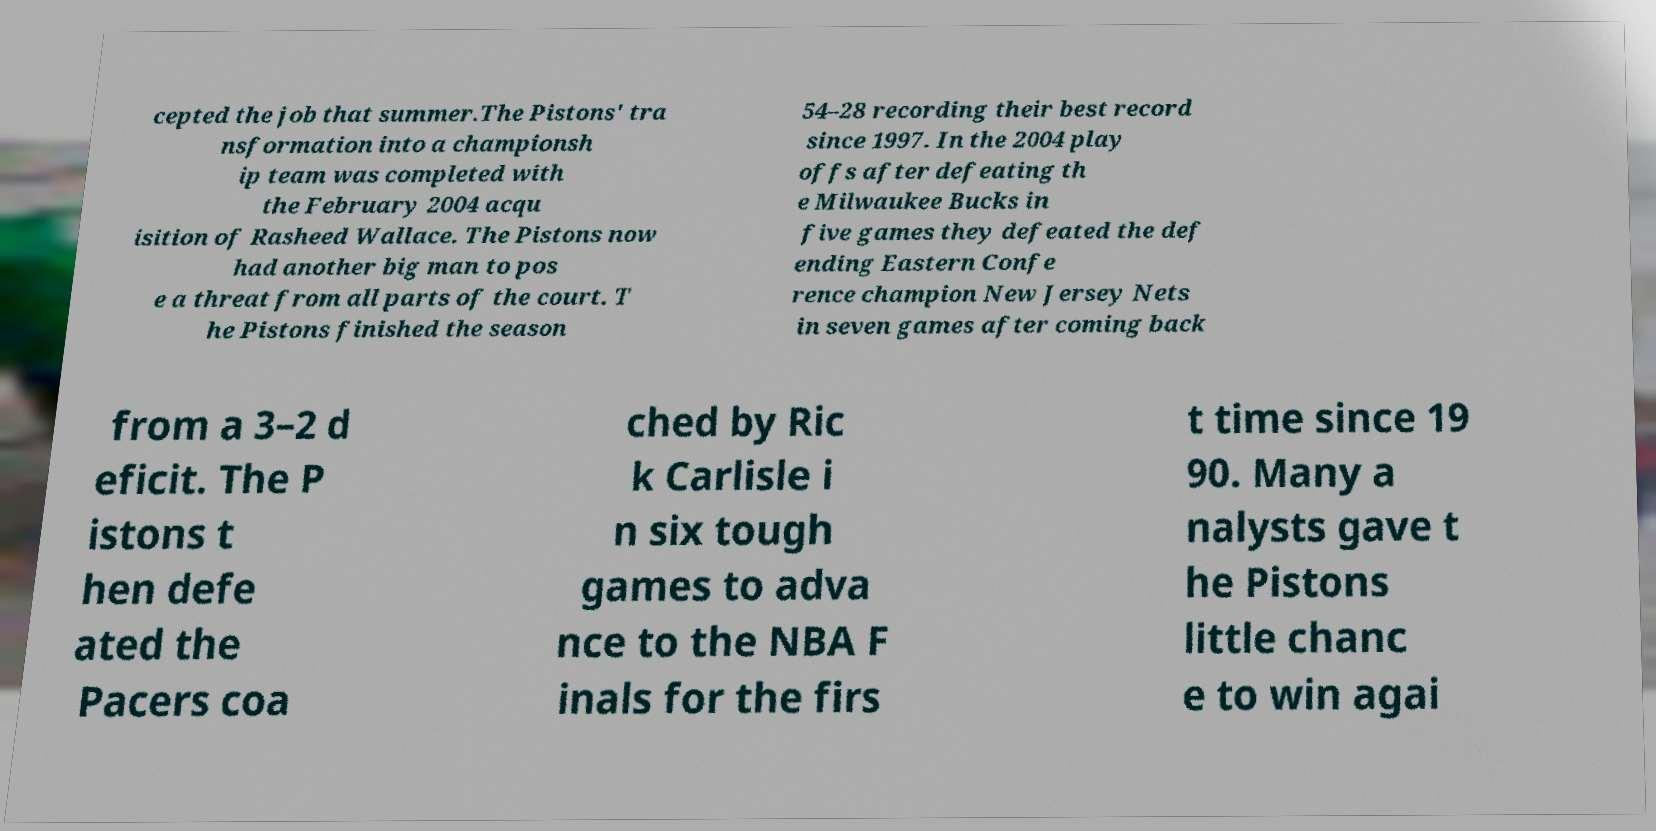What messages or text are displayed in this image? I need them in a readable, typed format. cepted the job that summer.The Pistons' tra nsformation into a championsh ip team was completed with the February 2004 acqu isition of Rasheed Wallace. The Pistons now had another big man to pos e a threat from all parts of the court. T he Pistons finished the season 54–28 recording their best record since 1997. In the 2004 play offs after defeating th e Milwaukee Bucks in five games they defeated the def ending Eastern Confe rence champion New Jersey Nets in seven games after coming back from a 3–2 d eficit. The P istons t hen defe ated the Pacers coa ched by Ric k Carlisle i n six tough games to adva nce to the NBA F inals for the firs t time since 19 90. Many a nalysts gave t he Pistons little chanc e to win agai 